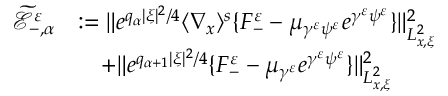Convert formula to latex. <formula><loc_0><loc_0><loc_500><loc_500>\begin{array} { r l } { \widetilde { \ m a t h s c r E } _ { - , \alpha } ^ { \varepsilon } } & { \colon = \| e ^ { q _ { \alpha } | \xi | ^ { 2 } / 4 } \langle \nabla _ { x } \rangle ^ { s } \{ F _ { - } ^ { \varepsilon } - \mu _ { \gamma ^ { \varepsilon } \psi ^ { \varepsilon } } e ^ { \gamma ^ { \varepsilon } \psi ^ { \varepsilon } } \} \| _ { L _ { x , \xi } ^ { 2 } } ^ { 2 } } \\ & { \quad + \| e ^ { q _ { \alpha + 1 } | \xi | ^ { 2 } / 4 } \{ F _ { - } ^ { \varepsilon } - \mu _ { \gamma ^ { \varepsilon } } e ^ { \gamma ^ { \varepsilon } \psi ^ { \varepsilon } } \} \| _ { L _ { x , \xi } ^ { 2 } } ^ { 2 } } \end{array}</formula> 